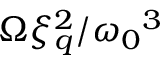<formula> <loc_0><loc_0><loc_500><loc_500>\Omega \xi _ { q } ^ { 2 } / { \omega _ { 0 } } ^ { 3 }</formula> 